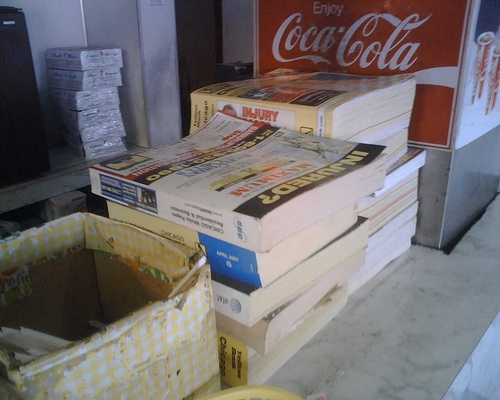Describe the objects in this image and their specific colors. I can see refrigerator in gray and maroon tones, book in gray and darkgray tones, book in gray, darkgray, and tan tones, book in gray, tan, lightgray, and blue tones, and book in gray, darkgray, lightgray, and black tones in this image. 